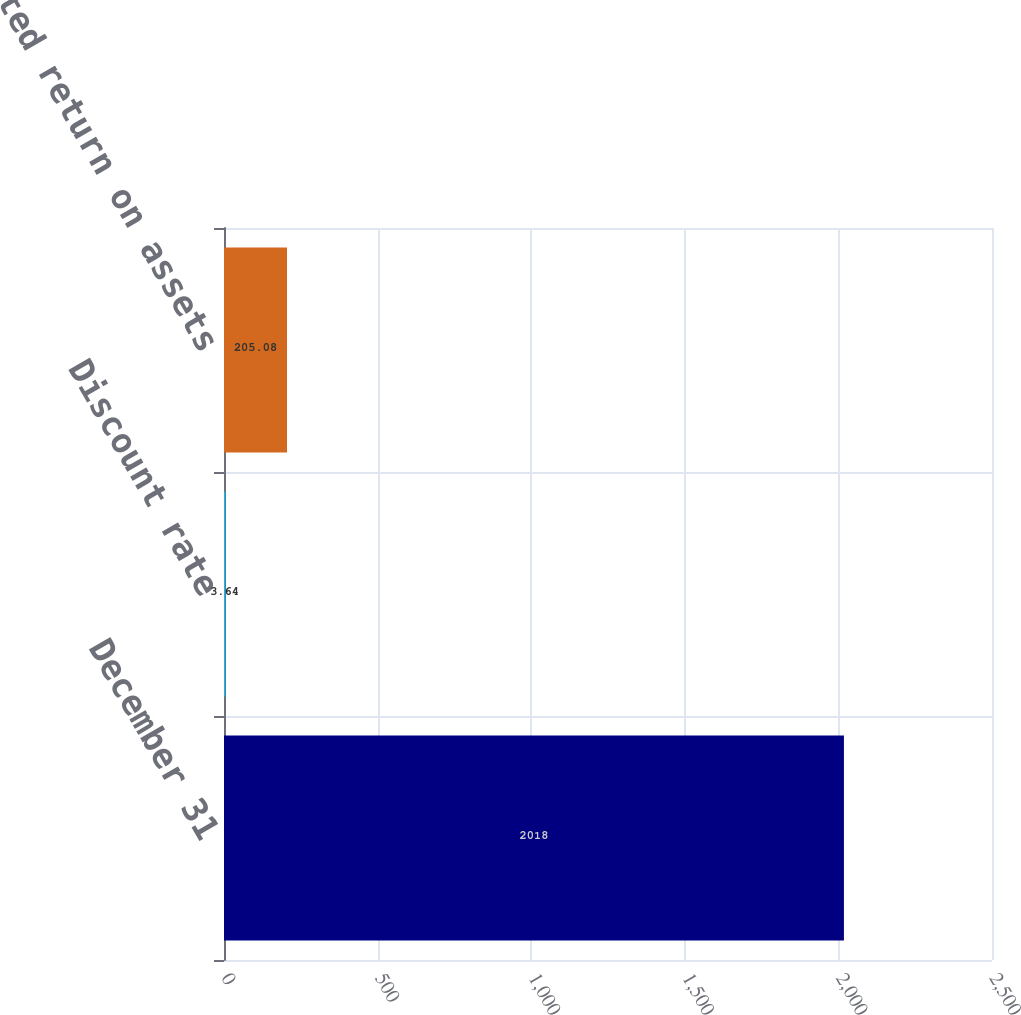<chart> <loc_0><loc_0><loc_500><loc_500><bar_chart><fcel>December 31<fcel>Discount rate<fcel>Expected return on assets<nl><fcel>2018<fcel>3.64<fcel>205.08<nl></chart> 